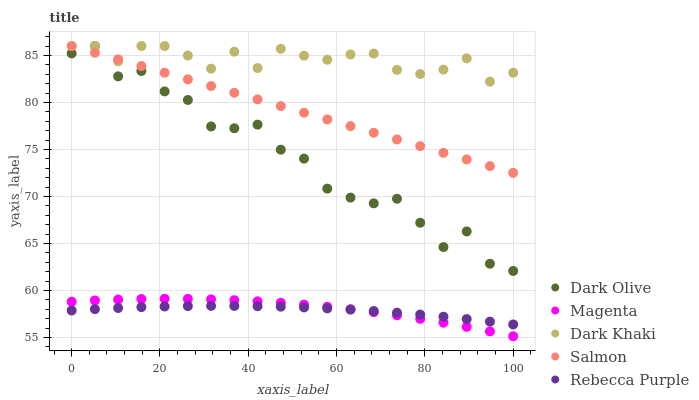Does Rebecca Purple have the minimum area under the curve?
Answer yes or no. Yes. Does Dark Khaki have the maximum area under the curve?
Answer yes or no. Yes. Does Magenta have the minimum area under the curve?
Answer yes or no. No. Does Magenta have the maximum area under the curve?
Answer yes or no. No. Is Salmon the smoothest?
Answer yes or no. Yes. Is Dark Olive the roughest?
Answer yes or no. Yes. Is Magenta the smoothest?
Answer yes or no. No. Is Magenta the roughest?
Answer yes or no. No. Does Magenta have the lowest value?
Answer yes or no. Yes. Does Dark Olive have the lowest value?
Answer yes or no. No. Does Salmon have the highest value?
Answer yes or no. Yes. Does Magenta have the highest value?
Answer yes or no. No. Is Magenta less than Dark Olive?
Answer yes or no. Yes. Is Salmon greater than Rebecca Purple?
Answer yes or no. Yes. Does Salmon intersect Dark Khaki?
Answer yes or no. Yes. Is Salmon less than Dark Khaki?
Answer yes or no. No. Is Salmon greater than Dark Khaki?
Answer yes or no. No. Does Magenta intersect Dark Olive?
Answer yes or no. No. 